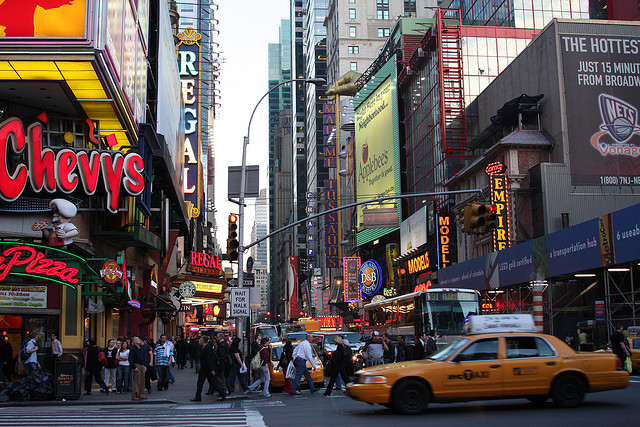<image>What common drugstore is found nearby? I don't know which drugstore is found nearby. It could be CVS, Walgreens, Rite Aid, or Duane Reade. What common drugstore is found nearby? There is a Walgreens drugstore nearby. 